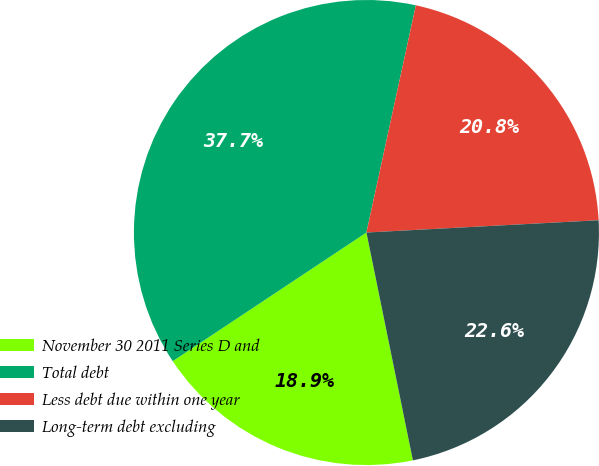<chart> <loc_0><loc_0><loc_500><loc_500><pie_chart><fcel>November 30 2011 Series D and<fcel>Total debt<fcel>Less debt due within one year<fcel>Long-term debt excluding<nl><fcel>18.87%<fcel>37.74%<fcel>20.75%<fcel>22.64%<nl></chart> 